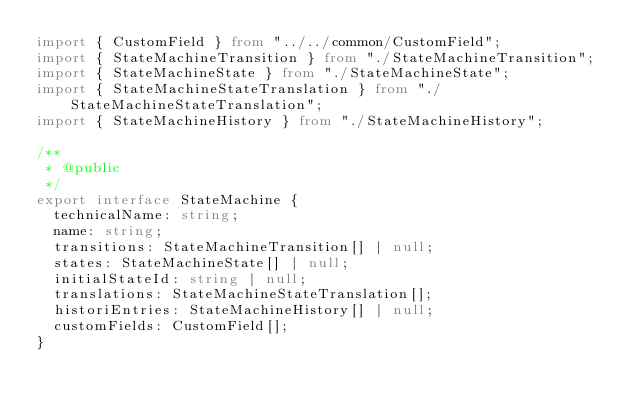<code> <loc_0><loc_0><loc_500><loc_500><_TypeScript_>import { CustomField } from "../../common/CustomField";
import { StateMachineTransition } from "./StateMachineTransition";
import { StateMachineState } from "./StateMachineState";
import { StateMachineStateTranslation } from "./StateMachineStateTranslation";
import { StateMachineHistory } from "./StateMachineHistory";

/**
 * @public
 */
export interface StateMachine {
  technicalName: string;
  name: string;
  transitions: StateMachineTransition[] | null;
  states: StateMachineState[] | null;
  initialStateId: string | null;
  translations: StateMachineStateTranslation[];
  historiEntries: StateMachineHistory[] | null;
  customFields: CustomField[];
}
</code> 